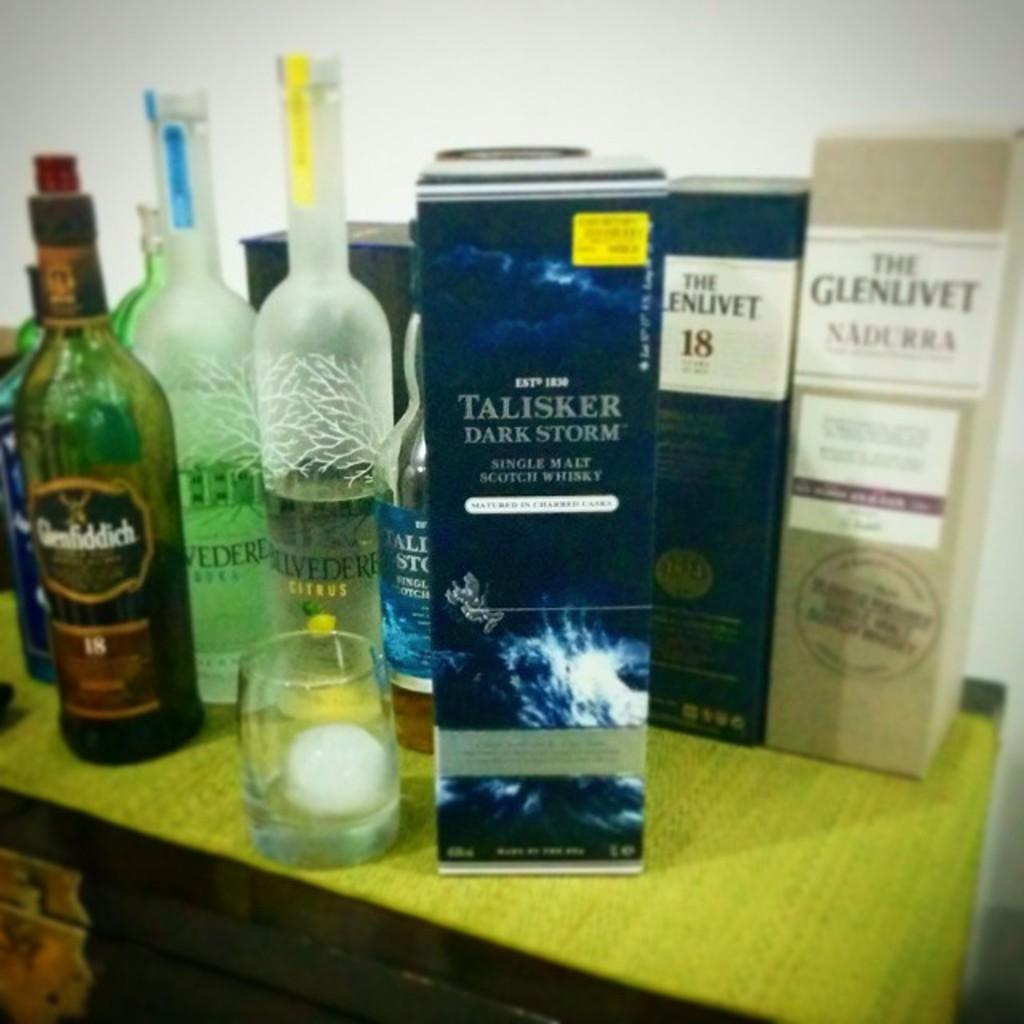<image>
Relay a brief, clear account of the picture shown. A boxed bottle of Talisker Dark Storm single malt Scotch Whiskey inside along the table with other types of alcohol. 